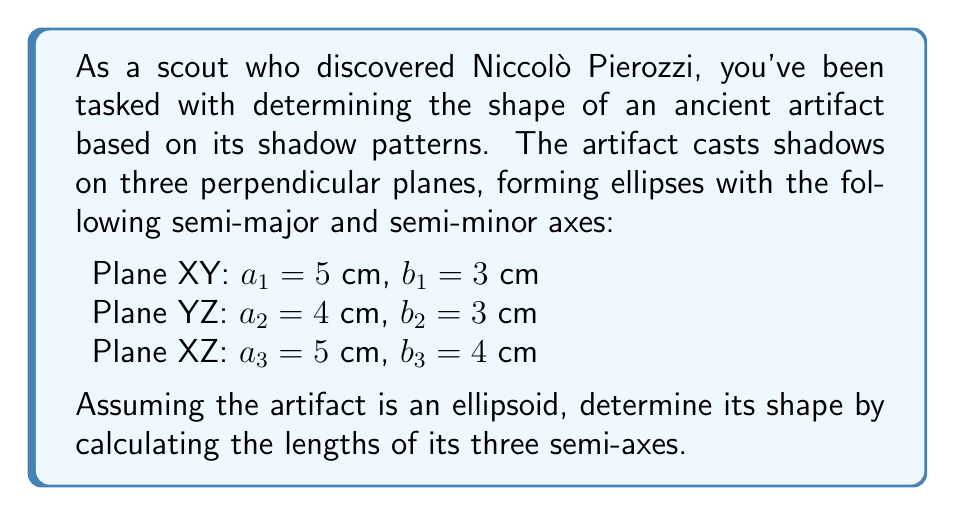Solve this math problem. To solve this problem, we'll follow these steps:

1) For an ellipsoid, the shadows on perpendicular planes are ellipses. The semi-axes of the ellipsoid are related to the semi-axes of these shadow ellipses.

2) Let the semi-axes of the ellipsoid be $x$, $y$, and $z$. The relationship between these and the shadow ellipses' semi-axes is:

   $$(x,y,z) = (\max(a_1,a_3), \max(a_1,a_2), \max(a_2,a_3))$$

3) From the given data:
   $a_1 = 5$, $a_2 = 4$, $a_3 = 5$

4) Applying the formula:
   $x = \max(a_1,a_3) = \max(5,5) = 5$
   $y = \max(a_1,a_2) = \max(5,4) = 5$
   $z = \max(a_2,a_3) = \max(4,5) = 5$

5) Therefore, the semi-axes of the ellipsoid are 5 cm, 5 cm, and 5 cm.

6) Since all semi-axes are equal, this ellipsoid is actually a sphere with radius 5 cm.
Answer: Sphere with radius 5 cm 